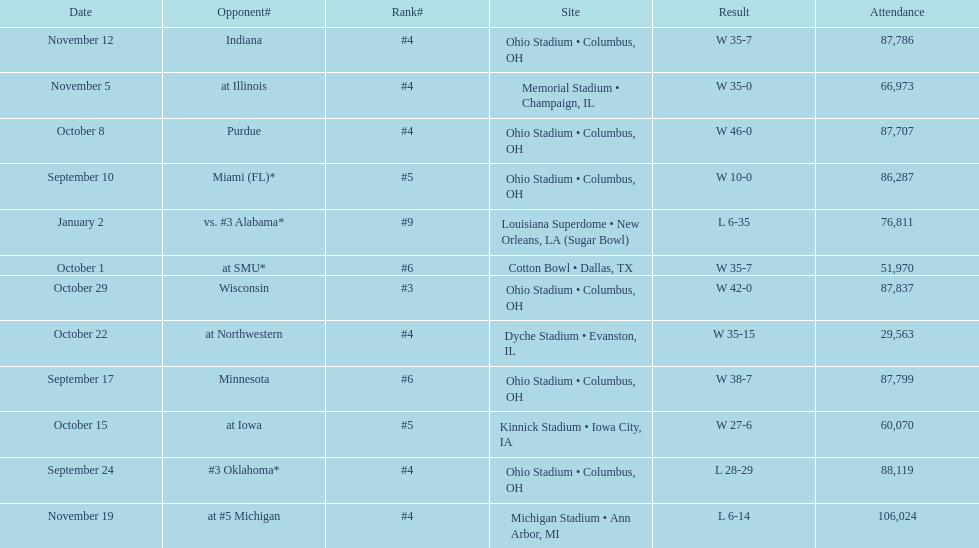What was the last game to be attended by fewer than 30,000 people? October 22. 